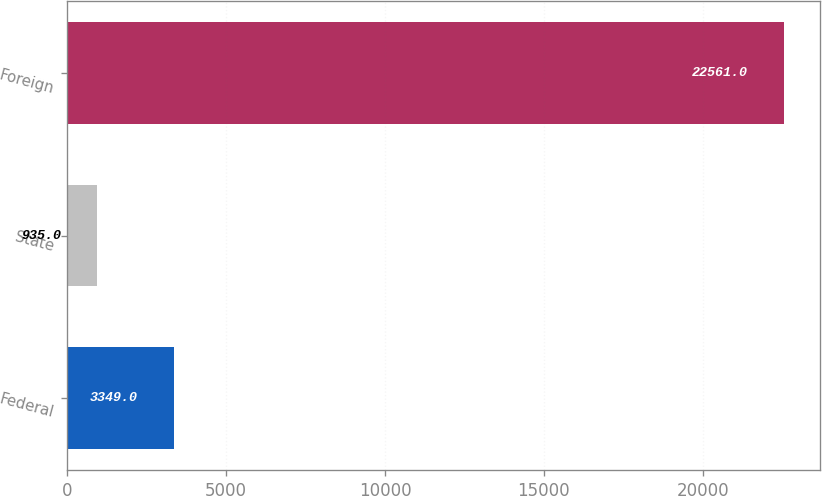Convert chart to OTSL. <chart><loc_0><loc_0><loc_500><loc_500><bar_chart><fcel>Federal<fcel>State<fcel>Foreign<nl><fcel>3349<fcel>935<fcel>22561<nl></chart> 